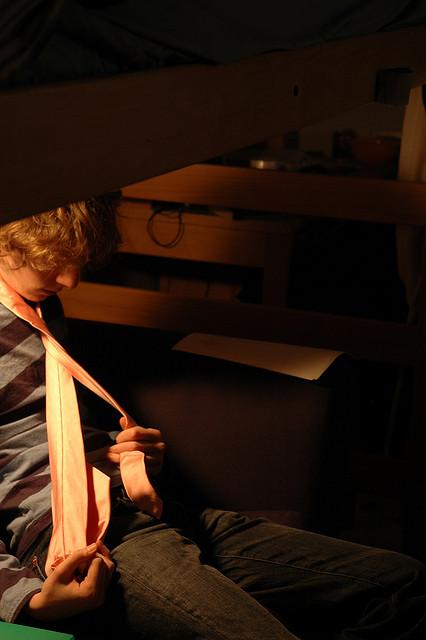Does the guy know how to tie his tie?
Write a very short answer. No. How many beds are pictured?
Be succinct. 1. Who is learning how to tie a knot?
Short answer required. Boy. 